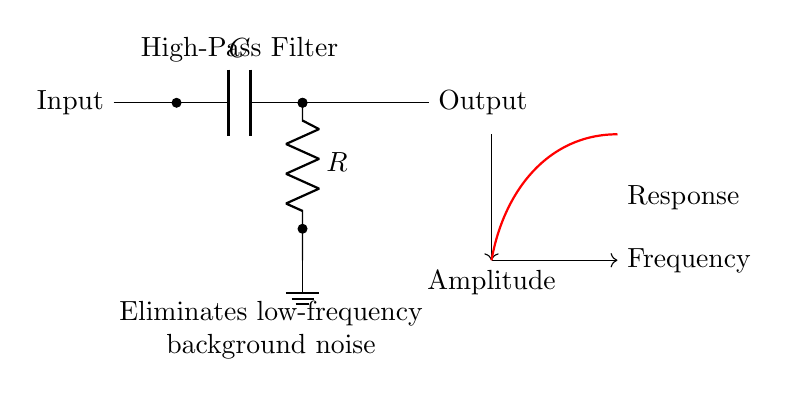What type of filter is represented in the circuit? The circuit diagram shows a high-pass filter, which allows high-frequency signals to pass while attenuating low-frequency signals. This is indicated by the label "High-Pass Filter" in the diagram.
Answer: High-pass filter What components are used in this circuit? The circuit includes a capacitor and a resistor, as labeled in the diagram. The capacitor is denoted by 'C' and the resistor by 'R'.
Answer: Capacitor and resistor What is the function of the capacitor in this circuit? The capacitor in a high-pass filter blocks low-frequency signals and allows high-frequency signals to pass, which is essential for the circuit's purpose of eliminating background noise.
Answer: Blocks low-frequency signals How does the output react to changes in frequency? As frequency increases, the output amplitude increases, which can be inferred from the frequency response curve shown in the diagram, indicating that high-frequency signals are amplified while low frequencies are attenuated.
Answer: Output amplitude increases What happens to the low-frequency signals in this circuit? The low-frequency signals are eliminated or attenuated due to the action of the capacitor which restricts such frequencies from passing through to the output.
Answer: Eliminated or attenuated What does the ground connection signify in this circuit? The ground connection provides a reference point for the voltage levels in the circuit and helps in the stabilization of the circuit's performance. It represents a common return path for electric current.
Answer: Reference point for voltage 